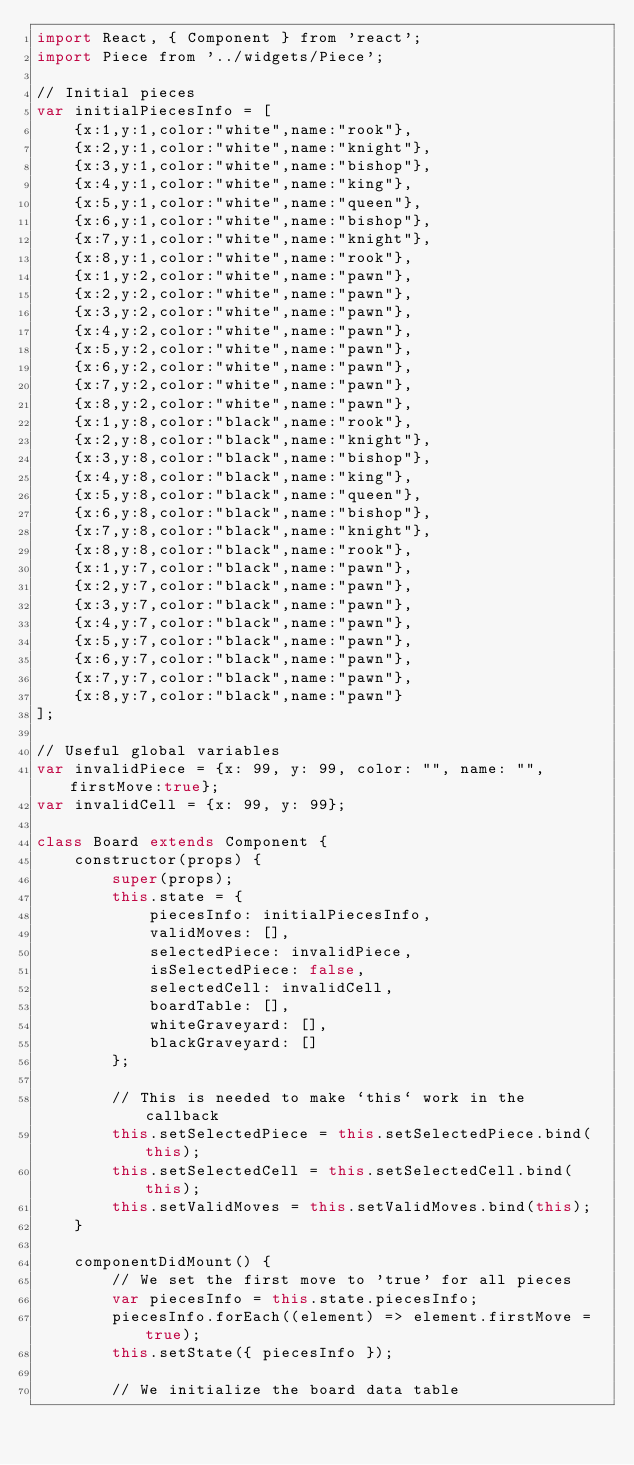Convert code to text. <code><loc_0><loc_0><loc_500><loc_500><_JavaScript_>import React, { Component } from 'react'; 
import Piece from '../widgets/Piece';

// Initial pieces
var initialPiecesInfo = [
    {x:1,y:1,color:"white",name:"rook"},
    {x:2,y:1,color:"white",name:"knight"},
    {x:3,y:1,color:"white",name:"bishop"},
    {x:4,y:1,color:"white",name:"king"},
    {x:5,y:1,color:"white",name:"queen"},
    {x:6,y:1,color:"white",name:"bishop"},
    {x:7,y:1,color:"white",name:"knight"},
    {x:8,y:1,color:"white",name:"rook"},
    {x:1,y:2,color:"white",name:"pawn"},
    {x:2,y:2,color:"white",name:"pawn"},
    {x:3,y:2,color:"white",name:"pawn"},
    {x:4,y:2,color:"white",name:"pawn"},
    {x:5,y:2,color:"white",name:"pawn"},
    {x:6,y:2,color:"white",name:"pawn"},
    {x:7,y:2,color:"white",name:"pawn"},
    {x:8,y:2,color:"white",name:"pawn"},
    {x:1,y:8,color:"black",name:"rook"},
    {x:2,y:8,color:"black",name:"knight"},
    {x:3,y:8,color:"black",name:"bishop"},
    {x:4,y:8,color:"black",name:"king"},
    {x:5,y:8,color:"black",name:"queen"},
    {x:6,y:8,color:"black",name:"bishop"},
    {x:7,y:8,color:"black",name:"knight"},
    {x:8,y:8,color:"black",name:"rook"},
    {x:1,y:7,color:"black",name:"pawn"},
    {x:2,y:7,color:"black",name:"pawn"},
    {x:3,y:7,color:"black",name:"pawn"},
    {x:4,y:7,color:"black",name:"pawn"},
    {x:5,y:7,color:"black",name:"pawn"},
    {x:6,y:7,color:"black",name:"pawn"},
    {x:7,y:7,color:"black",name:"pawn"},
    {x:8,y:7,color:"black",name:"pawn"}
];

// Useful global variables
var invalidPiece = {x: 99, y: 99, color: "", name: "", firstMove:true};
var invalidCell = {x: 99, y: 99};

class Board extends Component {
    constructor(props) {
        super(props);
        this.state = {
            piecesInfo: initialPiecesInfo,
            validMoves: [],
            selectedPiece: invalidPiece,
            isSelectedPiece: false,
            selectedCell: invalidCell,
            boardTable: [],
            whiteGraveyard: [],
            blackGraveyard: []
        };
        
        // This is needed to make `this` work in the callback
        this.setSelectedPiece = this.setSelectedPiece.bind(this);
        this.setSelectedCell = this.setSelectedCell.bind(this);
        this.setValidMoves = this.setValidMoves.bind(this);
    }

    componentDidMount() {
        // We set the first move to 'true' for all pieces
        var piecesInfo = this.state.piecesInfo;
        piecesInfo.forEach((element) => element.firstMove = true);
        this.setState({ piecesInfo });

        // We initialize the board data table</code> 